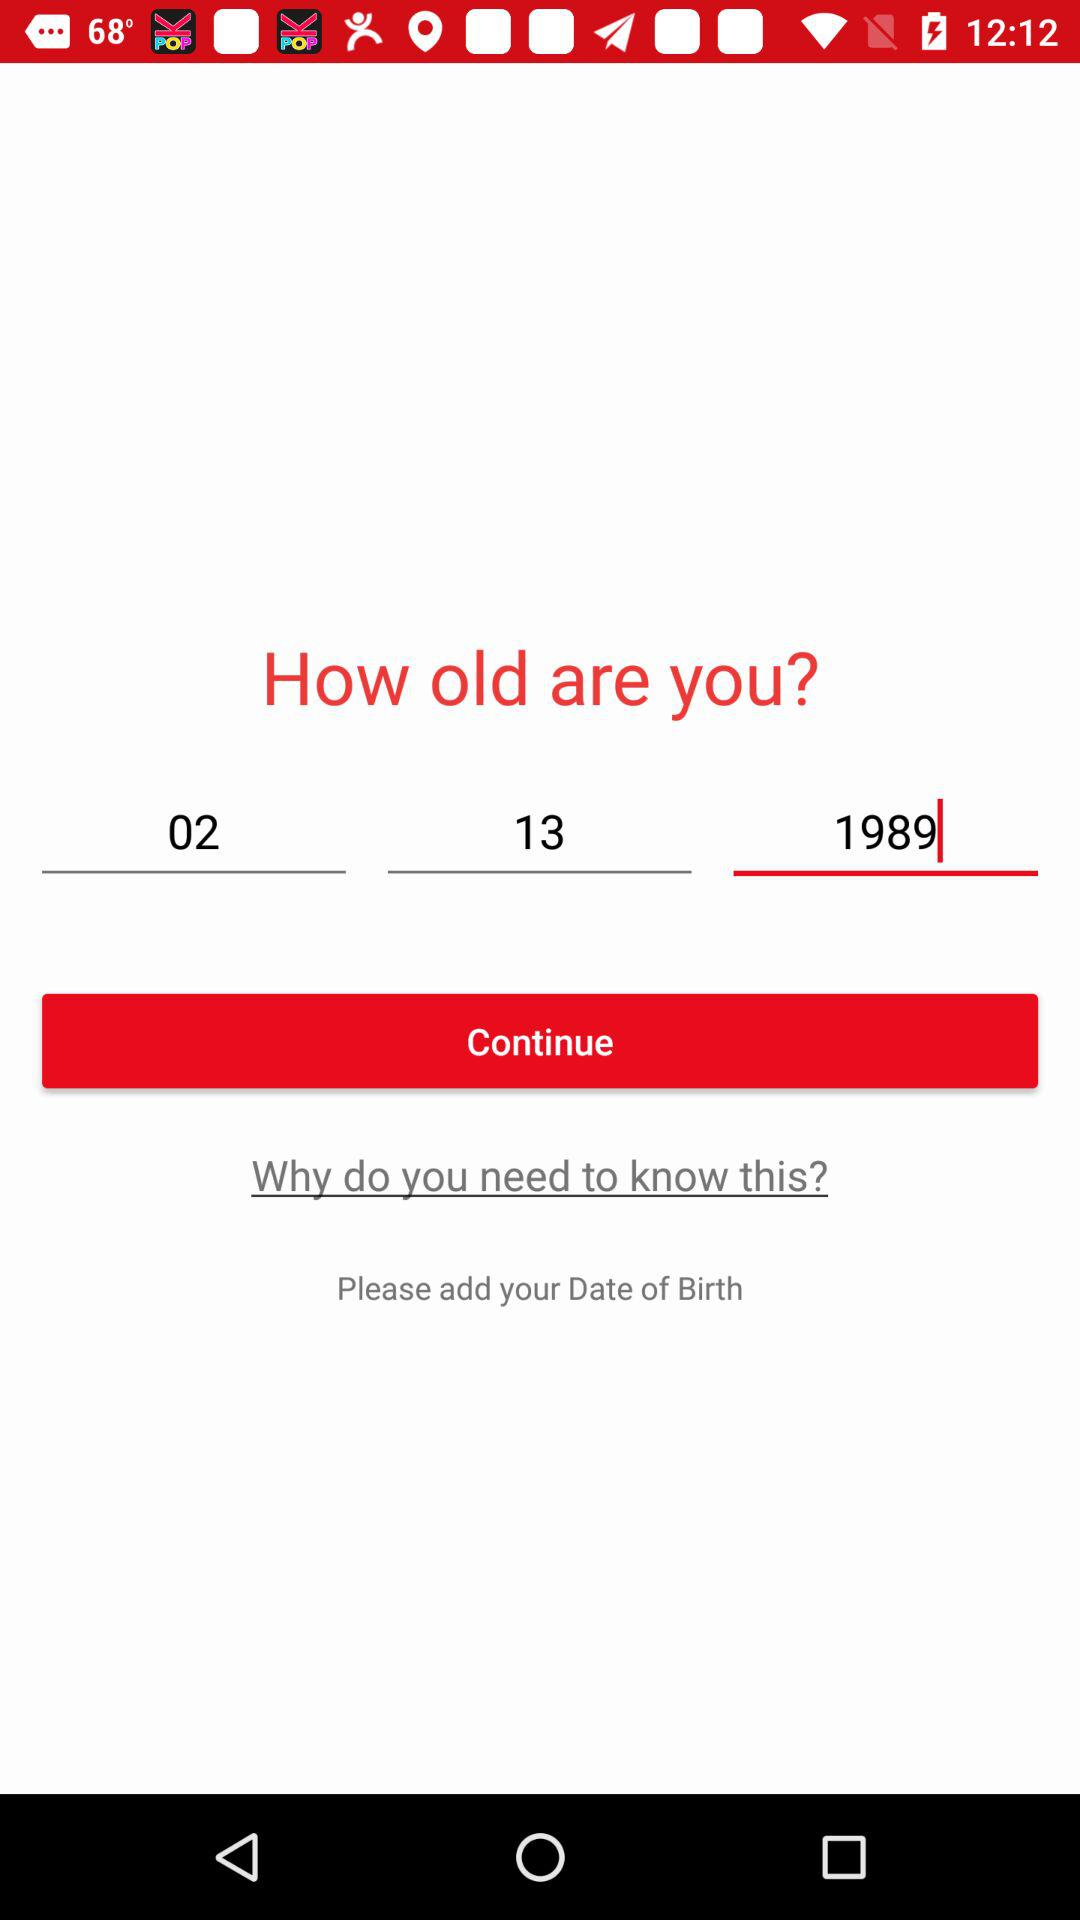Which year is selected for the date of birth? The selected year is 1989. 